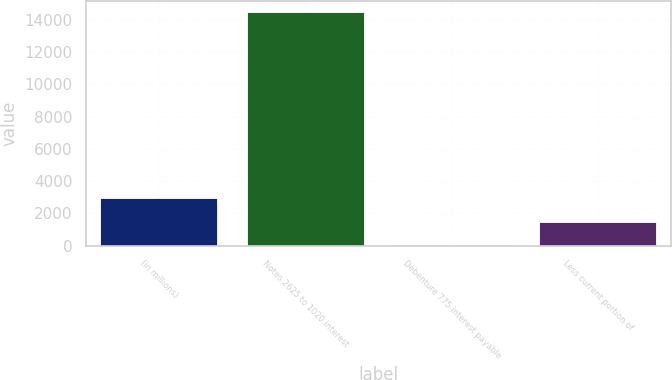Convert chart to OTSL. <chart><loc_0><loc_0><loc_500><loc_500><bar_chart><fcel>(in millions)<fcel>Notes 2625 to 1020 interest<fcel>Debenture 775 interest payable<fcel>Less current portion of<nl><fcel>2928.6<fcel>14475<fcel>42<fcel>1485.3<nl></chart> 